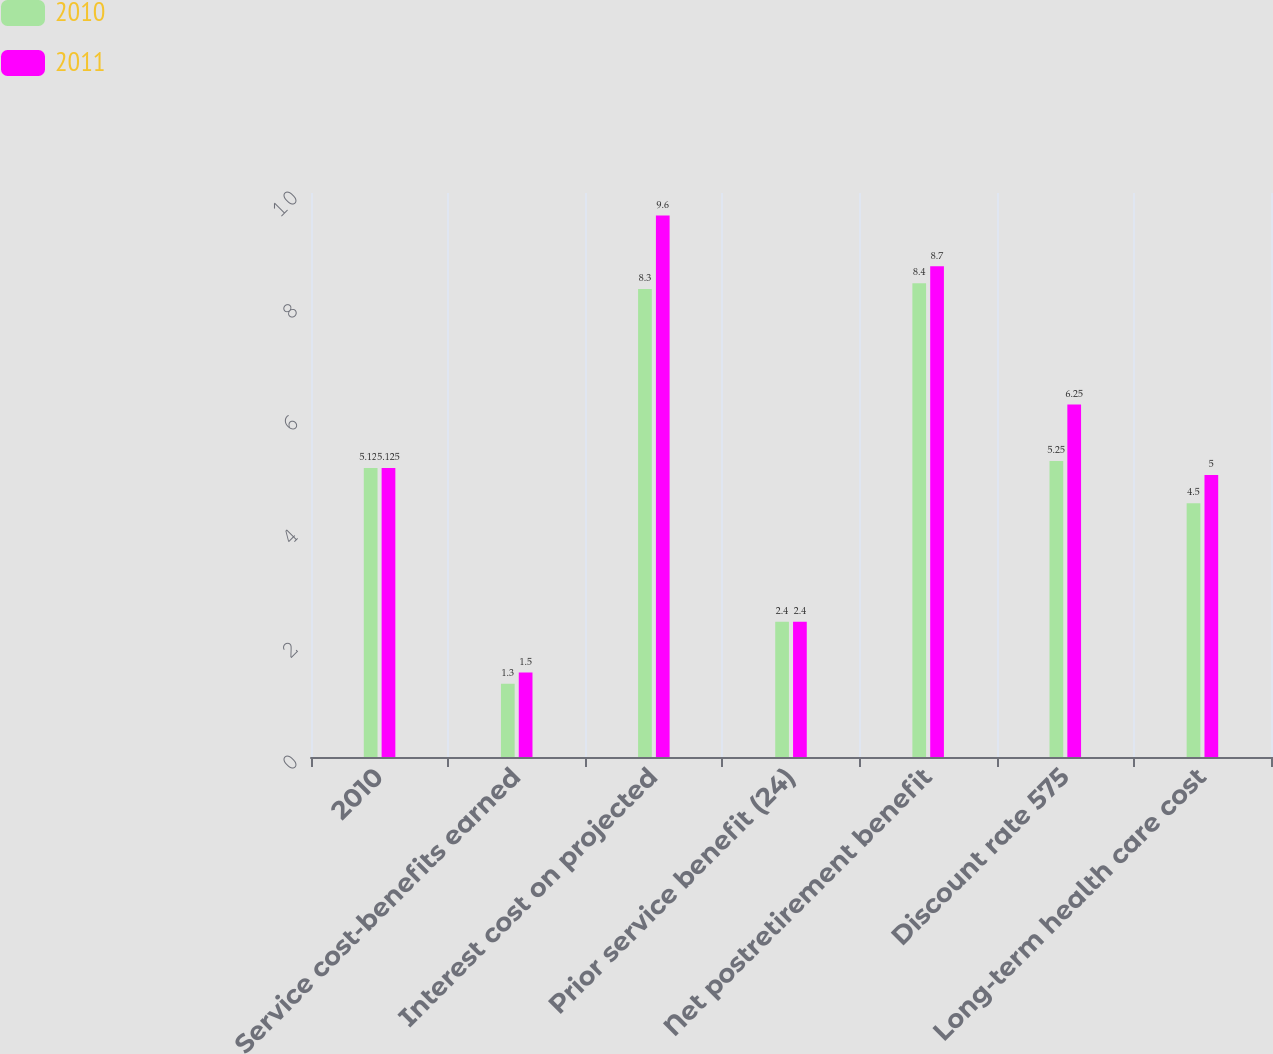Convert chart to OTSL. <chart><loc_0><loc_0><loc_500><loc_500><stacked_bar_chart><ecel><fcel>2010<fcel>Service cost-benefits earned<fcel>Interest cost on projected<fcel>Prior service benefit (24)<fcel>Net postretirement benefit<fcel>Discount rate 575<fcel>Long-term health care cost<nl><fcel>2010<fcel>5.125<fcel>1.3<fcel>8.3<fcel>2.4<fcel>8.4<fcel>5.25<fcel>4.5<nl><fcel>2011<fcel>5.125<fcel>1.5<fcel>9.6<fcel>2.4<fcel>8.7<fcel>6.25<fcel>5<nl></chart> 